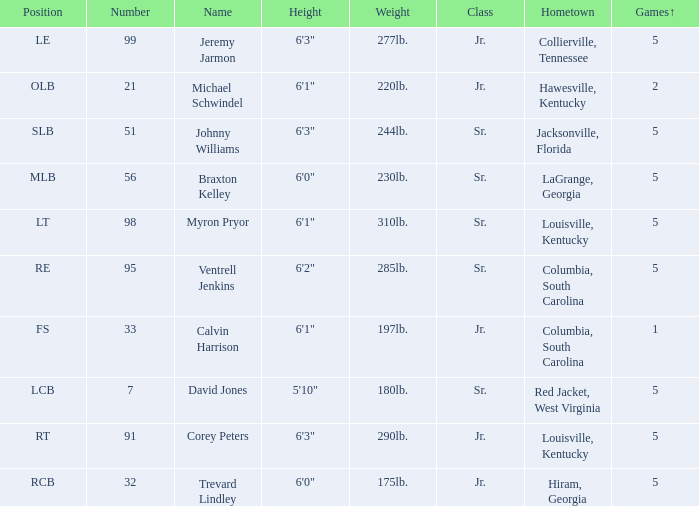How many players were 6'1" and from Columbia, South Carolina? 1.0. Would you mind parsing the complete table? {'header': ['Position', 'Number', 'Name', 'Height', 'Weight', 'Class', 'Hometown', 'Games↑'], 'rows': [['LE', '99', 'Jeremy Jarmon', '6\'3"', '277lb.', 'Jr.', 'Collierville, Tennessee', '5'], ['OLB', '21', 'Michael Schwindel', '6\'1"', '220lb.', 'Jr.', 'Hawesville, Kentucky', '2'], ['SLB', '51', 'Johnny Williams', '6\'3"', '244lb.', 'Sr.', 'Jacksonville, Florida', '5'], ['MLB', '56', 'Braxton Kelley', '6\'0"', '230lb.', 'Sr.', 'LaGrange, Georgia', '5'], ['LT', '98', 'Myron Pryor', '6\'1"', '310lb.', 'Sr.', 'Louisville, Kentucky', '5'], ['RE', '95', 'Ventrell Jenkins', '6\'2"', '285lb.', 'Sr.', 'Columbia, South Carolina', '5'], ['FS', '33', 'Calvin Harrison', '6\'1"', '197lb.', 'Jr.', 'Columbia, South Carolina', '1'], ['LCB', '7', 'David Jones', '5\'10"', '180lb.', 'Sr.', 'Red Jacket, West Virginia', '5'], ['RT', '91', 'Corey Peters', '6\'3"', '290lb.', 'Jr.', 'Louisville, Kentucky', '5'], ['RCB', '32', 'Trevard Lindley', '6\'0"', '175lb.', 'Jr.', 'Hiram, Georgia', '5']]} 